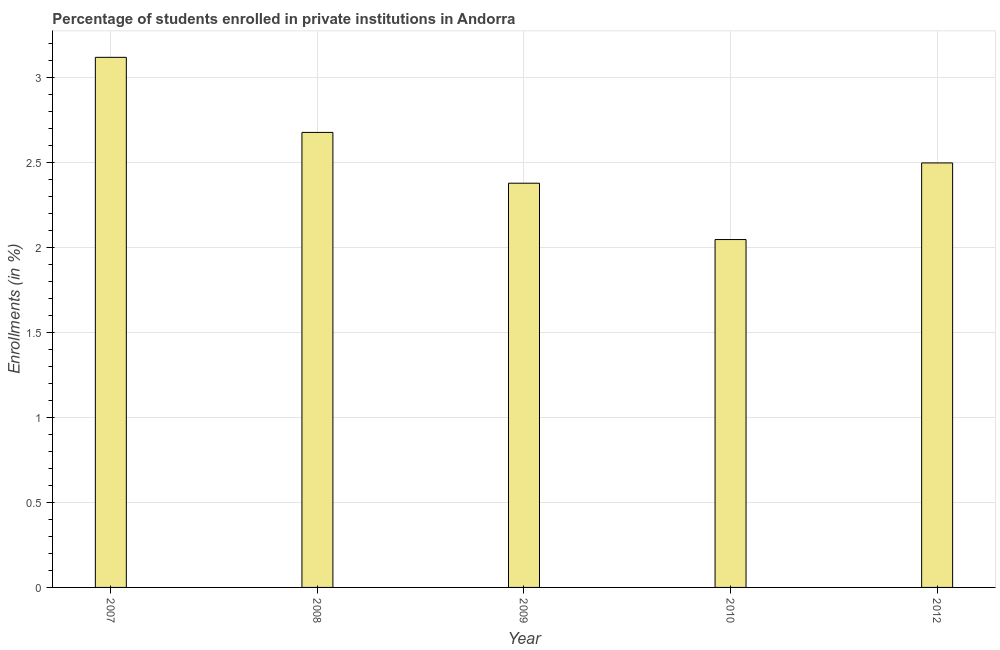What is the title of the graph?
Your response must be concise. Percentage of students enrolled in private institutions in Andorra. What is the label or title of the Y-axis?
Offer a very short reply. Enrollments (in %). What is the enrollments in private institutions in 2008?
Provide a short and direct response. 2.67. Across all years, what is the maximum enrollments in private institutions?
Make the answer very short. 3.12. Across all years, what is the minimum enrollments in private institutions?
Offer a very short reply. 2.04. In which year was the enrollments in private institutions maximum?
Your answer should be compact. 2007. In which year was the enrollments in private institutions minimum?
Make the answer very short. 2010. What is the sum of the enrollments in private institutions?
Your answer should be very brief. 12.71. What is the difference between the enrollments in private institutions in 2009 and 2010?
Your answer should be very brief. 0.33. What is the average enrollments in private institutions per year?
Make the answer very short. 2.54. What is the median enrollments in private institutions?
Make the answer very short. 2.5. In how many years, is the enrollments in private institutions greater than 2.1 %?
Your answer should be compact. 4. What is the ratio of the enrollments in private institutions in 2009 to that in 2012?
Offer a very short reply. 0.95. Is the difference between the enrollments in private institutions in 2009 and 2012 greater than the difference between any two years?
Ensure brevity in your answer.  No. What is the difference between the highest and the second highest enrollments in private institutions?
Your answer should be very brief. 0.44. Is the sum of the enrollments in private institutions in 2008 and 2012 greater than the maximum enrollments in private institutions across all years?
Offer a very short reply. Yes. What is the difference between the highest and the lowest enrollments in private institutions?
Make the answer very short. 1.07. How many bars are there?
Ensure brevity in your answer.  5. How many years are there in the graph?
Your answer should be compact. 5. What is the Enrollments (in %) of 2007?
Ensure brevity in your answer.  3.12. What is the Enrollments (in %) of 2008?
Ensure brevity in your answer.  2.67. What is the Enrollments (in %) in 2009?
Ensure brevity in your answer.  2.38. What is the Enrollments (in %) in 2010?
Make the answer very short. 2.04. What is the Enrollments (in %) in 2012?
Offer a terse response. 2.5. What is the difference between the Enrollments (in %) in 2007 and 2008?
Make the answer very short. 0.44. What is the difference between the Enrollments (in %) in 2007 and 2009?
Your response must be concise. 0.74. What is the difference between the Enrollments (in %) in 2007 and 2010?
Your answer should be very brief. 1.07. What is the difference between the Enrollments (in %) in 2007 and 2012?
Your answer should be compact. 0.62. What is the difference between the Enrollments (in %) in 2008 and 2009?
Ensure brevity in your answer.  0.3. What is the difference between the Enrollments (in %) in 2008 and 2010?
Make the answer very short. 0.63. What is the difference between the Enrollments (in %) in 2008 and 2012?
Your response must be concise. 0.18. What is the difference between the Enrollments (in %) in 2009 and 2010?
Your response must be concise. 0.33. What is the difference between the Enrollments (in %) in 2009 and 2012?
Give a very brief answer. -0.12. What is the difference between the Enrollments (in %) in 2010 and 2012?
Make the answer very short. -0.45. What is the ratio of the Enrollments (in %) in 2007 to that in 2008?
Provide a succinct answer. 1.17. What is the ratio of the Enrollments (in %) in 2007 to that in 2009?
Offer a very short reply. 1.31. What is the ratio of the Enrollments (in %) in 2007 to that in 2010?
Make the answer very short. 1.52. What is the ratio of the Enrollments (in %) in 2007 to that in 2012?
Your answer should be very brief. 1.25. What is the ratio of the Enrollments (in %) in 2008 to that in 2009?
Give a very brief answer. 1.13. What is the ratio of the Enrollments (in %) in 2008 to that in 2010?
Offer a terse response. 1.31. What is the ratio of the Enrollments (in %) in 2008 to that in 2012?
Keep it short and to the point. 1.07. What is the ratio of the Enrollments (in %) in 2009 to that in 2010?
Your response must be concise. 1.16. What is the ratio of the Enrollments (in %) in 2010 to that in 2012?
Provide a short and direct response. 0.82. 